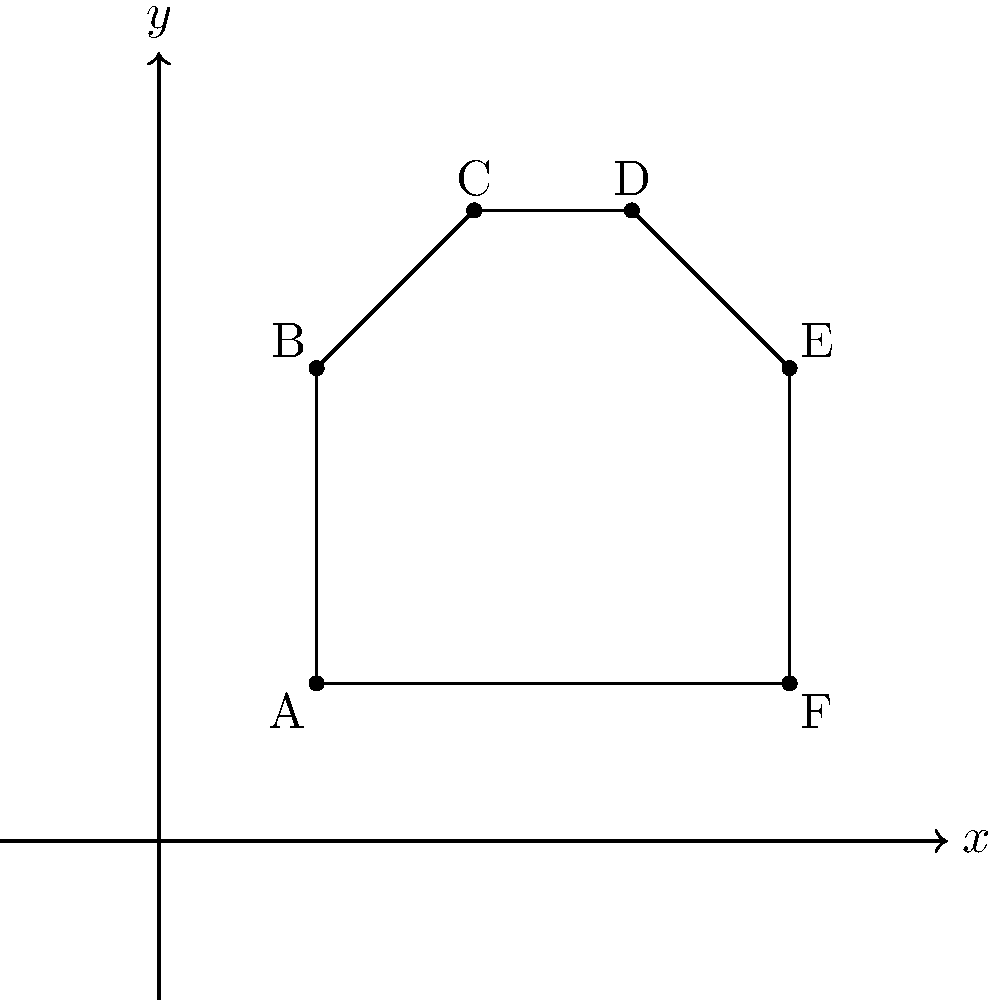Connect the dots labeled A, B, C, D, E, and F in order to create a simple picture of a hand. What are the coordinates of point C? To find the coordinates of point C, we need to:

1. Understand that coordinates are written as (x, y), where x is the horizontal position and y is the vertical position.
2. Look at the graph and find the point labeled C.
3. Determine its position on the x-axis (horizontal).
4. Determine its position on the y-axis (vertical).

Looking at the graph:
1. Point C is labeled on the picture.
2. Moving horizontally from the origin (0, 0), we see that C is at x = 2.
3. Moving vertically from the origin, we see that C is at y = 4.

Therefore, the coordinates of point C are (2, 4).
Answer: $(2, 4)$ 